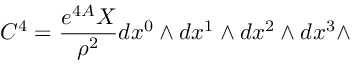Convert formula to latex. <formula><loc_0><loc_0><loc_500><loc_500>C ^ { 4 } = { \frac { e ^ { 4 A } X } { \rho ^ { 2 } } } d x ^ { 0 } \wedge d x ^ { 1 } \wedge d x ^ { 2 } \wedge d x ^ { 3 } \wedge</formula> 